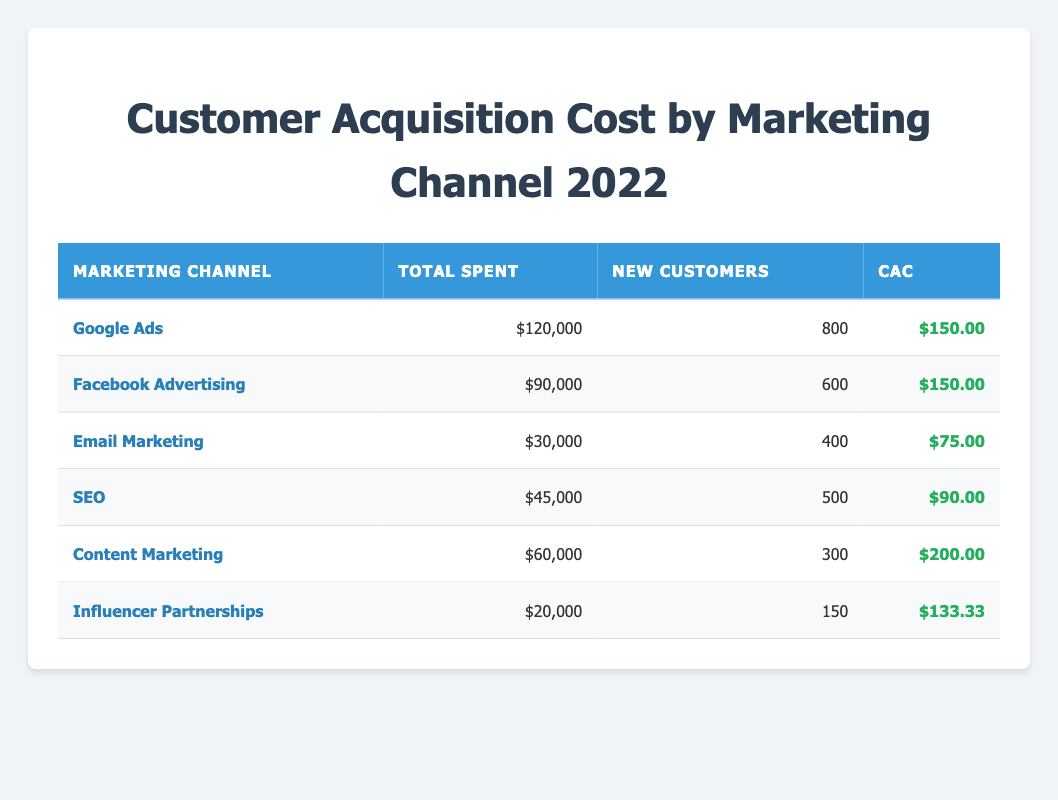What is the customer acquisition cost for Email Marketing? The table shows a row for Email Marketing with a CAC value of $75.00. This value directly answers the question without any further calculations.
Answer: $75.00 Which marketing channel had the highest total spent? Looking through each row in the "Total Spent" column, Google Ads reports the highest amount at $120,000. This is identified by scanning the values in the column for comparison.
Answer: Google Ads What is the average customer acquisition cost across all marketing channels? To find the average, add the CACs of all channels: 150 + 150 + 75 + 90 + 200 + 133.33 = 898.33. Then, divide by the number of channels (6): 898.33 / 6 = 149.72. This involves summing the CACs and then dividing by the count.
Answer: 149.72 Is the CAC for Influencer Partnerships lower than that of Content Marketing? The CAC for Influencer Partnerships is $133.33, while Content Marketing has a CAC of $200. This requires comparing the two values directly. Since $133.33 < $200, the answer is yes.
Answer: Yes Which marketing channel had the lowest total spent? Examining the "Total Spent" values, Influencer Partnerships showed the lowest spend at $20,000. This is determined by finding the minimum value in that column.
Answer: Influencer Partnerships What is the total number of new customers acquired from all marketing channels combined? For the total new customers, sum up the "New Customers" column: 800 + 600 + 400 + 500 + 300 + 150 = 2750. This requires adding each new customer figure together.
Answer: 2750 Are there any marketing channels with a CAC higher than $150? In the CAC column, only Content Marketing has a CAC of $200, which is higher than $150. Checking the CAC values across the table confirms this.
Answer: Yes What is the difference in total spent between Google Ads and Facebook Advertising? Google Ads has spent $120,000 while Facebook Advertising has spent $90,000. The difference is $120,000 - $90,000 = $30,000. This entails simple subtraction of the two total amounts.
Answer: $30,000 